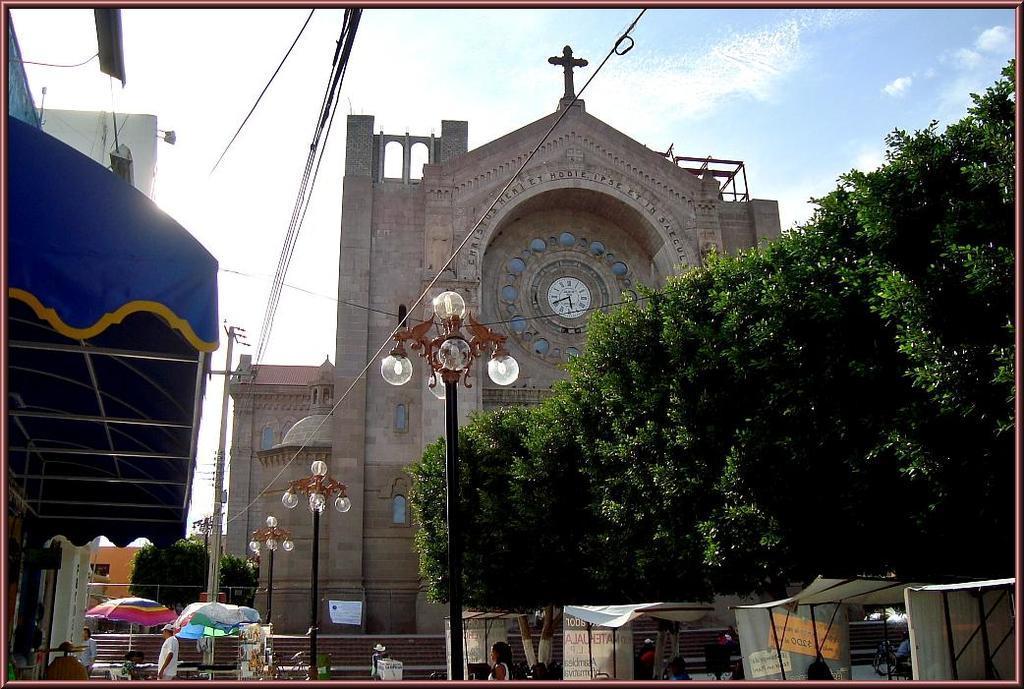How would you summarize this image in a sentence or two? In this image we can see the tents, light poles, wires, current pole, umbrellas, people walking on the road, trees, fence, stone building where a clock is fixed in the center and the sky with clouds in the background. 